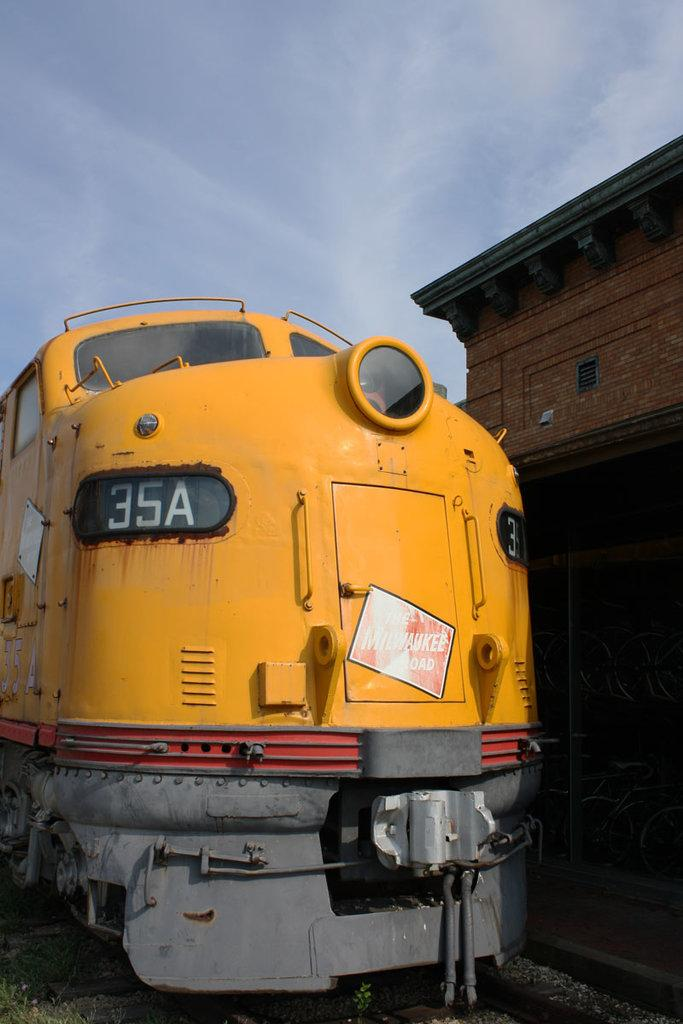<image>
Render a clear and concise summary of the photo. an old, slightly rusty train has a window with the numbers 35A in it 